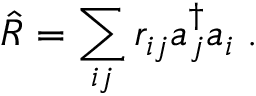Convert formula to latex. <formula><loc_0><loc_0><loc_500><loc_500>\hat { R } = \sum _ { i j } r _ { i j } a _ { j } ^ { \dagger } a _ { i } \, .</formula> 